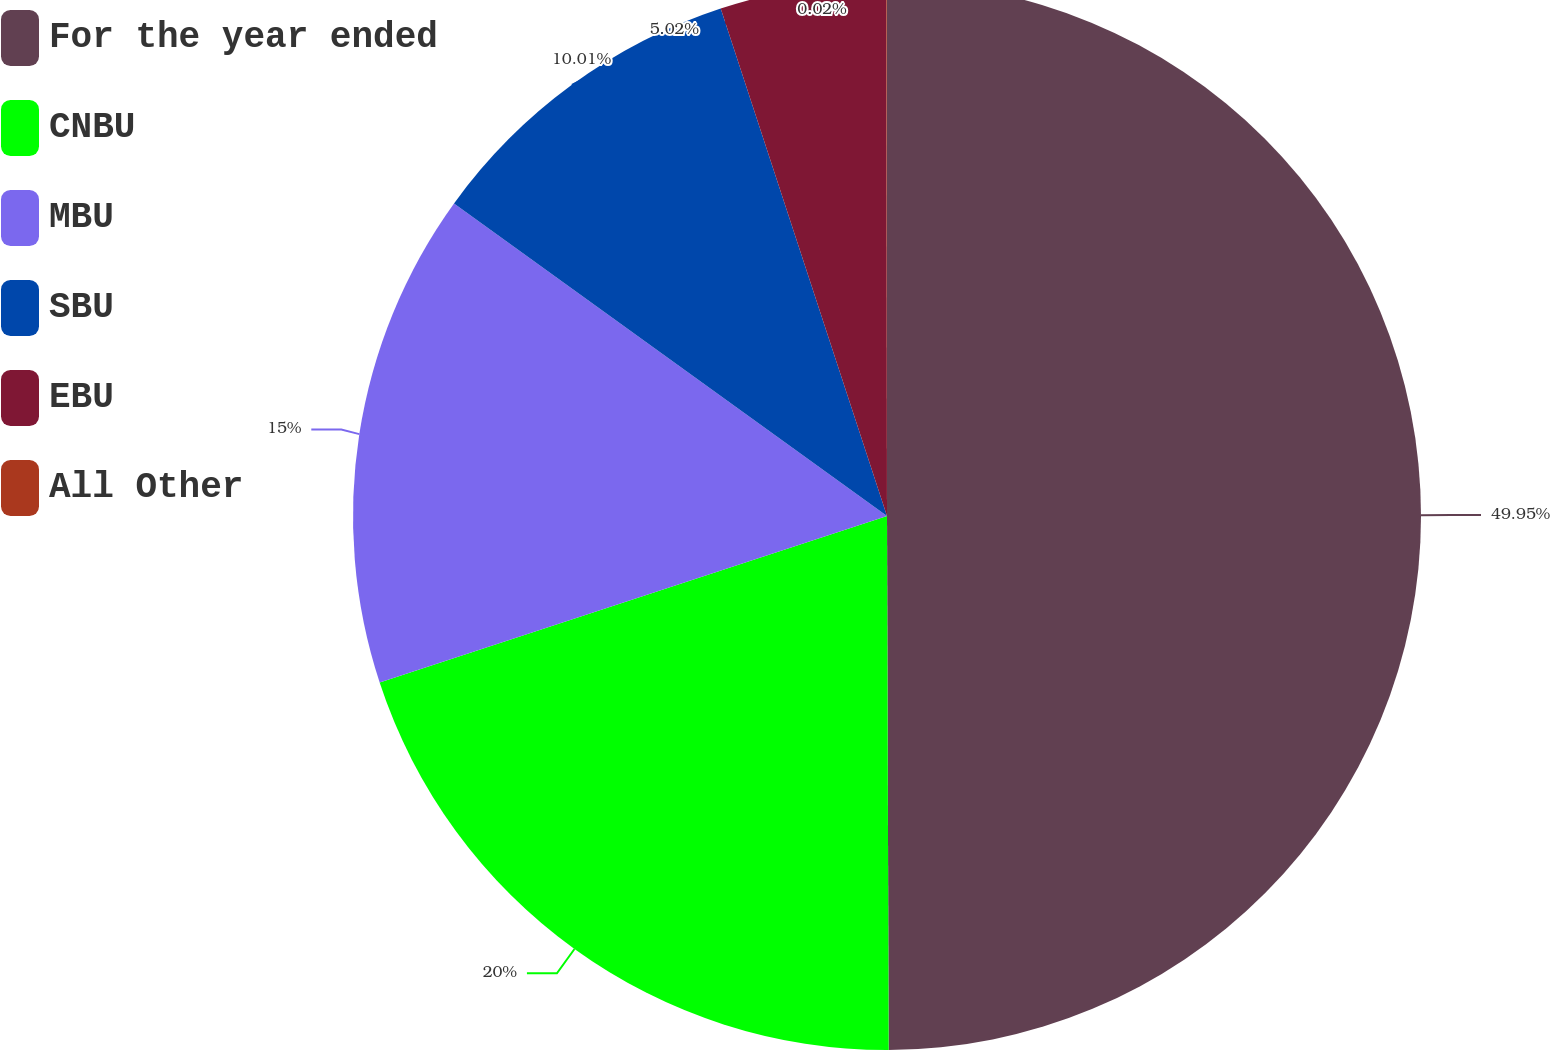Convert chart. <chart><loc_0><loc_0><loc_500><loc_500><pie_chart><fcel>For the year ended<fcel>CNBU<fcel>MBU<fcel>SBU<fcel>EBU<fcel>All Other<nl><fcel>49.95%<fcel>20.0%<fcel>15.0%<fcel>10.01%<fcel>5.02%<fcel>0.02%<nl></chart> 